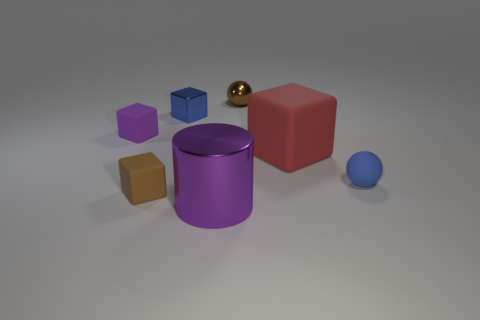There is another small cube that is made of the same material as the tiny brown block; what is its color?
Offer a very short reply. Purple. How many tiny blocks are the same material as the big red block?
Keep it short and to the point. 2. How many blue matte cubes are there?
Your answer should be compact. 0. There is a tiny metallic thing that is on the left side of the large shiny cylinder; is its color the same as the sphere behind the small purple cube?
Make the answer very short. No. There is a tiny metal cube; how many blue objects are in front of it?
Ensure brevity in your answer.  1. There is a object that is the same color as the shiny cylinder; what is it made of?
Ensure brevity in your answer.  Rubber. Are there any big yellow metal things that have the same shape as the tiny brown metallic object?
Offer a very short reply. No. Does the brown object that is in front of the tiny metallic block have the same material as the small ball left of the big red object?
Your response must be concise. No. There is a blue object that is to the right of the tiny brown thing behind the tiny blue object to the left of the purple cylinder; what is its size?
Offer a very short reply. Small. There is a red block that is the same size as the purple metal cylinder; what is its material?
Provide a short and direct response. Rubber. 